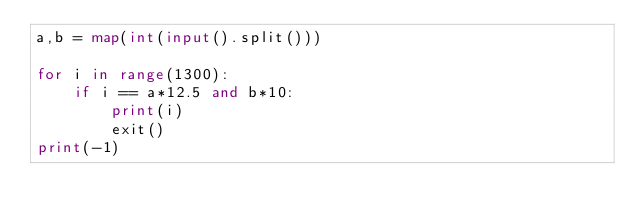Convert code to text. <code><loc_0><loc_0><loc_500><loc_500><_Python_>a,b = map(int(input().split()))

for i in range(1300):
    if i == a*12.5 and b*10:
        print(i)
        exit()
print(-1)</code> 